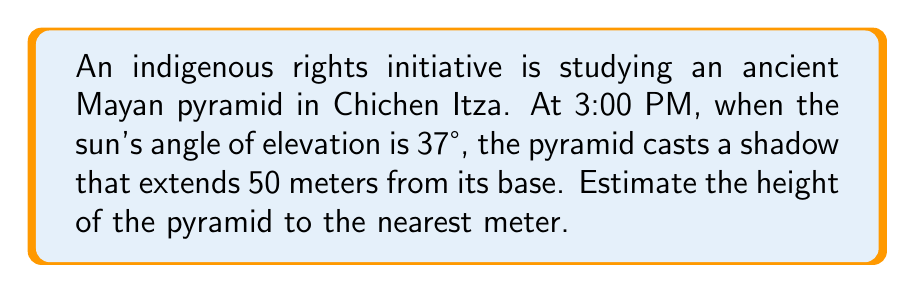Show me your answer to this math problem. Let's approach this step-by-step using trigonometry:

1) We can model this scenario as a right triangle, where:
   - The pyramid's height is the opposite side
   - The shadow's length is the adjacent side
   - The sun's rays form the hypotenuse

2) We know:
   - The angle of elevation of the sun: $\theta = 37°$
   - The length of the shadow (adjacent): $a = 50$ meters

3) We need to find the height of the pyramid (opposite side). The tangent function relates the opposite and adjacent sides:

   $$\tan \theta = \frac{\text{opposite}}{\text{adjacent}} = \frac{\text{height}}{\text{shadow length}}$$

4) Let's call the height $h$. We can write:

   $$\tan 37° = \frac{h}{50}$$

5) To solve for $h$, multiply both sides by 50:

   $$h = 50 \tan 37°$$

6) Using a calculator (or trigonometric tables):

   $$h = 50 \times 0.7535 = 37.675 \text{ meters}$$

7) Rounding to the nearest meter:

   $$h \approx 38 \text{ meters}$$
Answer: 38 meters 